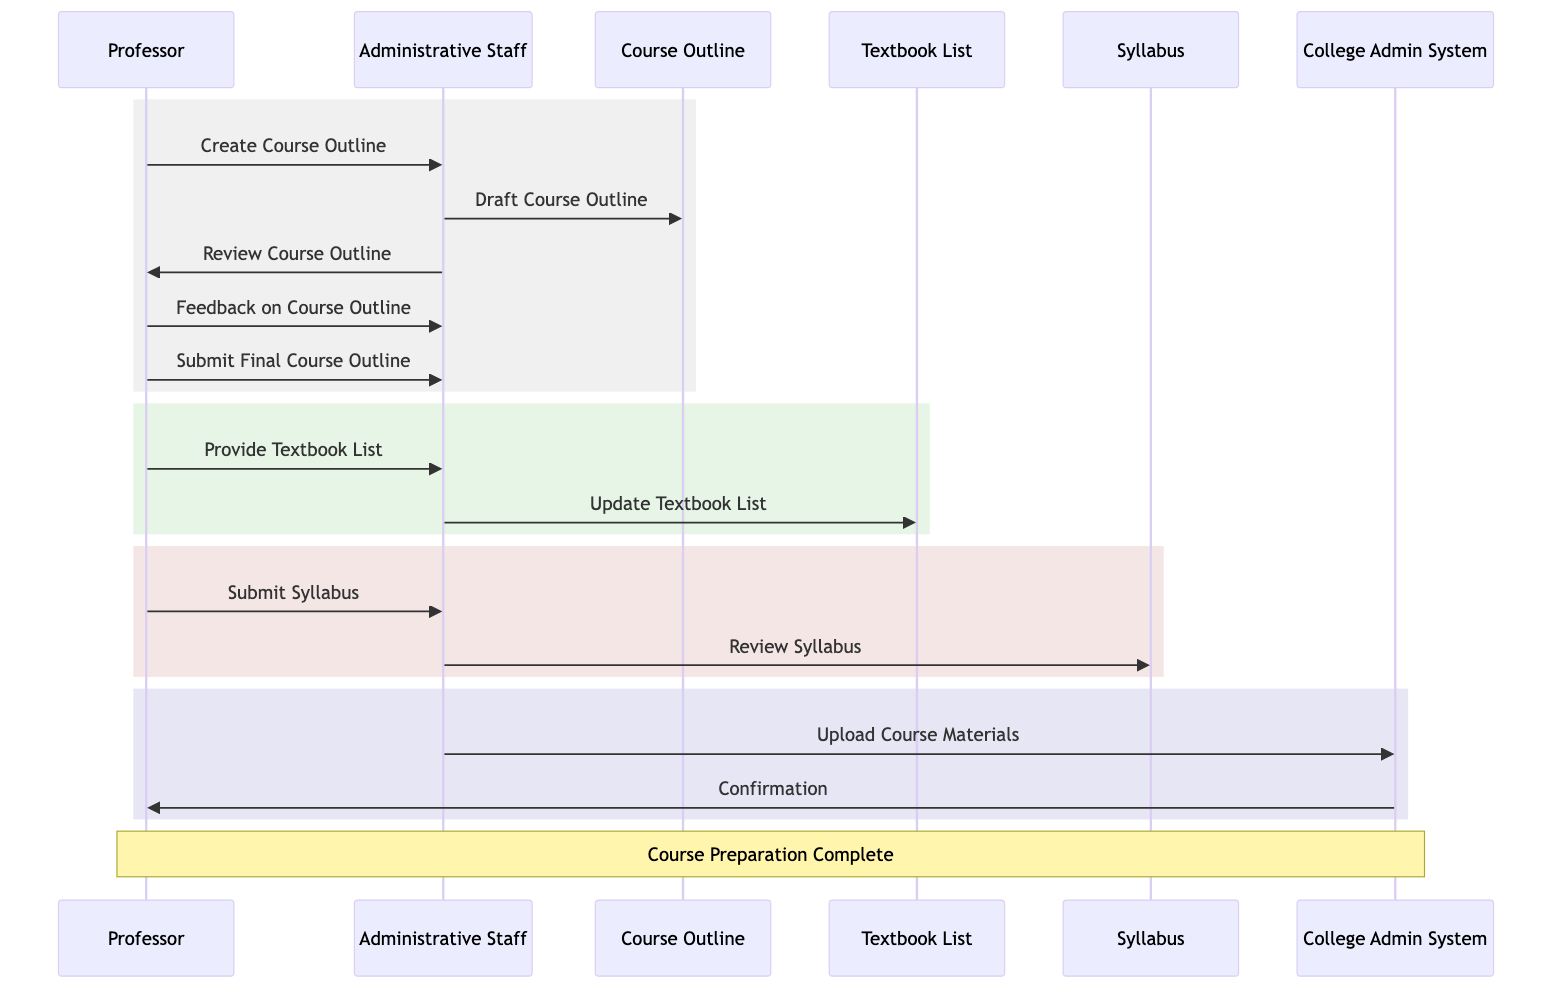What actor initiates the course outline creation? The diagram shows that the "Professor" sends a message titled "Create Course Outline" to the "Administrative Staff", clearly indicating that the professor is the one who initiates this action.
Answer: Professor How many materials are uploaded to the college admin system? The diagram indicates that three materials are uploaded: the course outline, textbook list, and syllabus, all of which are specified in the segment where "Upload Course Materials" takes place.
Answer: Three Who provides feedback on the course outline? In the diagram, the "Professor" is shown sending a message titled "Feedback on Course Outline" to the "Administrative Staff", indicating that it is the professor who provides this feedback.
Answer: Professor What follows the review of the syllabus by the administrative staff? After the "Review Syllabus" message from "Administrative Staff" to "Syllabus", the next action is illustrated as "Upload Course Materials" from "Administrative Staff" to "College Admin System", indicating that uploading follows the review.
Answer: Upload Course Materials What is the final step in the course preparation process? The sequence diagram concludes with the "College Admin System" sending a "Confirmation" message to the "Professor", marking it as the final step of the course preparation process.
Answer: Confirmation How are the course materials updated after providing the textbook list? After the "Provide Textbook List" message from the "Professor" to "Administrative Staff", the subsequent message shows "Update Textbook List" being sent from "Administrative Staff" to "Textbook List", which indicates the updating action taken on the textbook list.
Answer: Update Textbook List What is requested from the administrative staff by the professor when preparing the syllabus? The professor sends a message titled "Submit Syllabus", indicating a request for the administrative staff to take the detailed syllabus into consideration for the course materials.
Answer: Submit Syllabus What system is used for managing course materials? In the diagram, the "College Admin System" is mentioned several times, indicating that this is the system used for managing the course materials and schedules throughout the preparation process.
Answer: College Admin System 